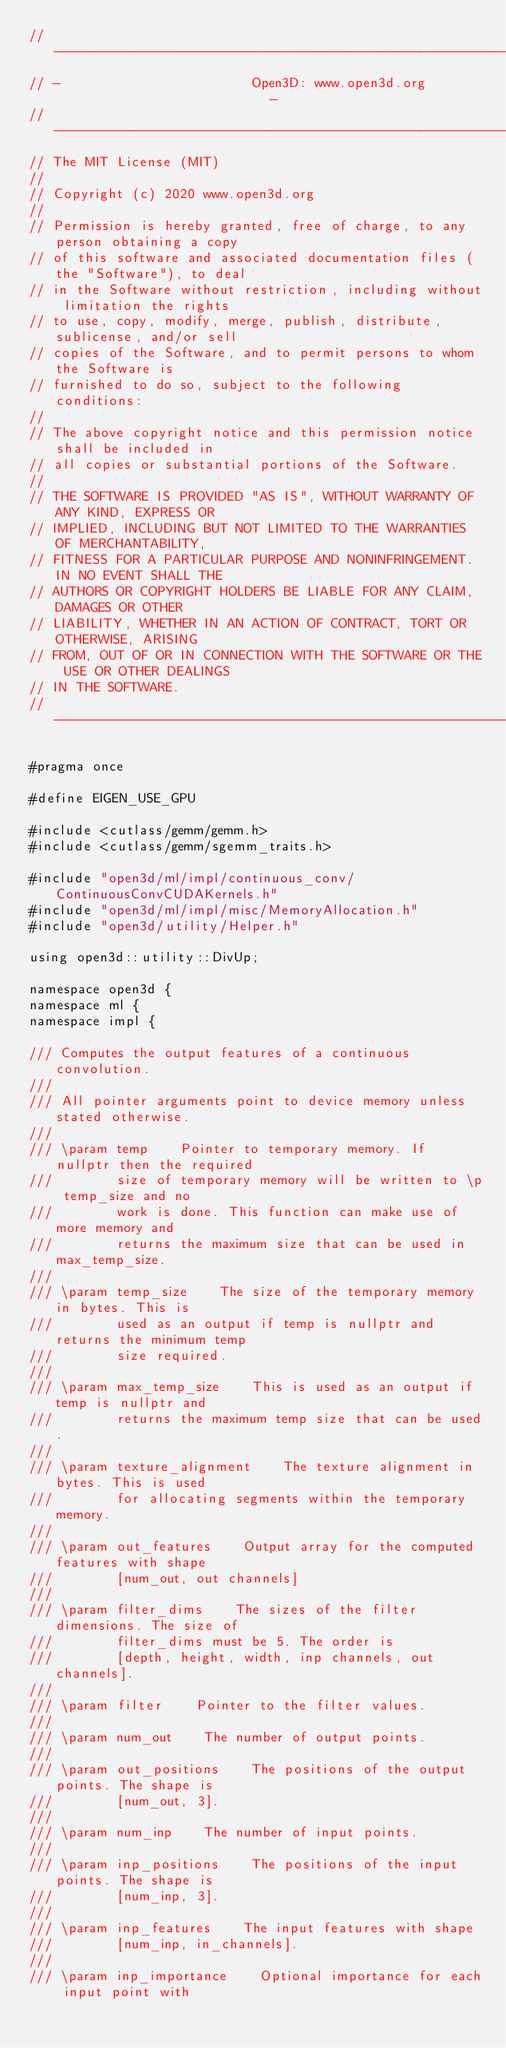Convert code to text. <code><loc_0><loc_0><loc_500><loc_500><_Cuda_>// ----------------------------------------------------------------------------
// -                        Open3D: www.open3d.org                            -
// ----------------------------------------------------------------------------
// The MIT License (MIT)
//
// Copyright (c) 2020 www.open3d.org
//
// Permission is hereby granted, free of charge, to any person obtaining a copy
// of this software and associated documentation files (the "Software"), to deal
// in the Software without restriction, including without limitation the rights
// to use, copy, modify, merge, publish, distribute, sublicense, and/or sell
// copies of the Software, and to permit persons to whom the Software is
// furnished to do so, subject to the following conditions:
//
// The above copyright notice and this permission notice shall be included in
// all copies or substantial portions of the Software.
//
// THE SOFTWARE IS PROVIDED "AS IS", WITHOUT WARRANTY OF ANY KIND, EXPRESS OR
// IMPLIED, INCLUDING BUT NOT LIMITED TO THE WARRANTIES OF MERCHANTABILITY,
// FITNESS FOR A PARTICULAR PURPOSE AND NONINFRINGEMENT. IN NO EVENT SHALL THE
// AUTHORS OR COPYRIGHT HOLDERS BE LIABLE FOR ANY CLAIM, DAMAGES OR OTHER
// LIABILITY, WHETHER IN AN ACTION OF CONTRACT, TORT OR OTHERWISE, ARISING
// FROM, OUT OF OR IN CONNECTION WITH THE SOFTWARE OR THE USE OR OTHER DEALINGS
// IN THE SOFTWARE.
// ----------------------------------------------------------------------------

#pragma once

#define EIGEN_USE_GPU

#include <cutlass/gemm/gemm.h>
#include <cutlass/gemm/sgemm_traits.h>

#include "open3d/ml/impl/continuous_conv/ContinuousConvCUDAKernels.h"
#include "open3d/ml/impl/misc/MemoryAllocation.h"
#include "open3d/utility/Helper.h"

using open3d::utility::DivUp;

namespace open3d {
namespace ml {
namespace impl {

/// Computes the output features of a continuous convolution.
///
/// All pointer arguments point to device memory unless stated otherwise.
///
/// \param temp    Pointer to temporary memory. If nullptr then the required
///        size of temporary memory will be written to \p temp_size and no
///        work is done. This function can make use of more memory and
///        returns the maximum size that can be used in max_temp_size.
///
/// \param temp_size    The size of the temporary memory in bytes. This is
///        used as an output if temp is nullptr and returns the minimum temp
///        size required.
///
/// \param max_temp_size    This is used as an output if temp is nullptr and
///        returns the maximum temp size that can be used.
///
/// \param texture_alignment    The texture alignment in bytes. This is used
///        for allocating segments within the temporary memory.
///
/// \param out_features    Output array for the computed features with shape
///        [num_out, out channels]
///
/// \param filter_dims    The sizes of the filter dimensions. The size of
///        filter_dims must be 5. The order is
///        [depth, height, width, inp channels, out channels].
///
/// \param filter    Pointer to the filter values.
///
/// \param num_out    The number of output points.
///
/// \param out_positions    The positions of the output points. The shape is
///        [num_out, 3].
///
/// \param num_inp    The number of input points.
///
/// \param inp_positions    The positions of the input points. The shape is
///        [num_inp, 3].
///
/// \param inp_features    The input features with shape
///        [num_inp, in_channels].
///
/// \param inp_importance    Optional importance for each input point with</code> 